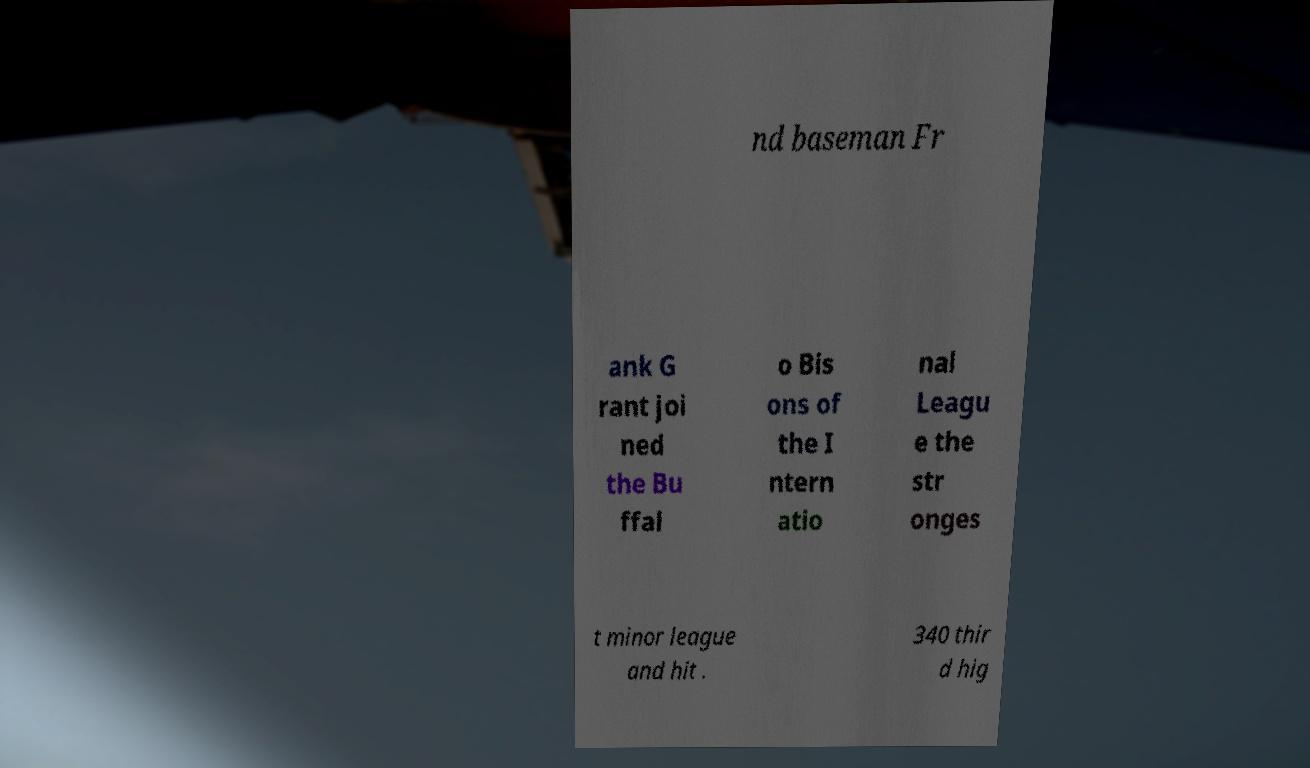For documentation purposes, I need the text within this image transcribed. Could you provide that? nd baseman Fr ank G rant joi ned the Bu ffal o Bis ons of the I ntern atio nal Leagu e the str onges t minor league and hit . 340 thir d hig 